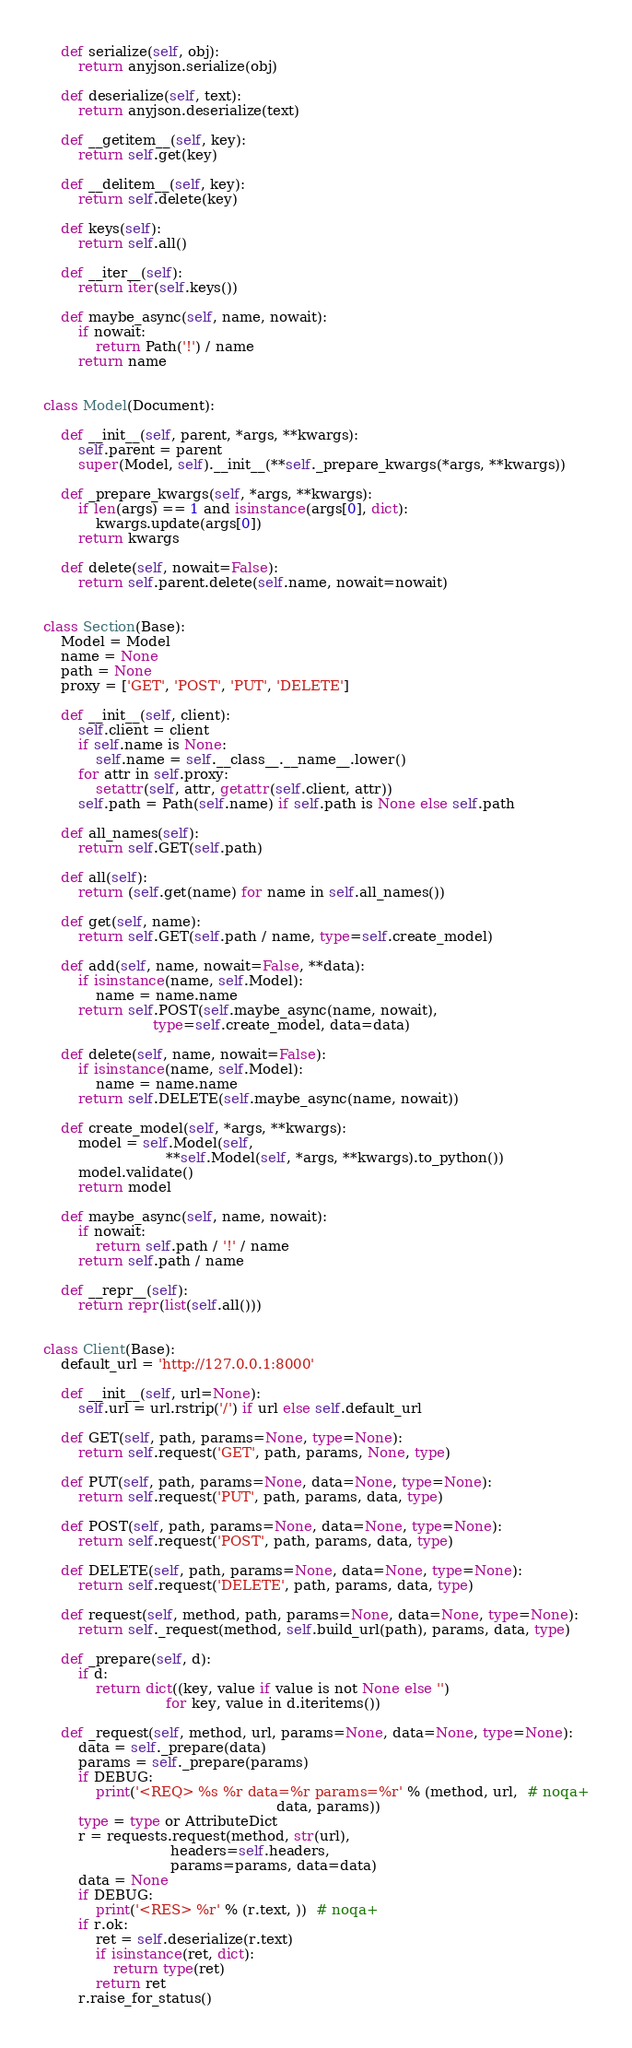Convert code to text. <code><loc_0><loc_0><loc_500><loc_500><_Python_>
    def serialize(self, obj):
        return anyjson.serialize(obj)

    def deserialize(self, text):
        return anyjson.deserialize(text)

    def __getitem__(self, key):
        return self.get(key)

    def __delitem__(self, key):
        return self.delete(key)

    def keys(self):
        return self.all()

    def __iter__(self):
        return iter(self.keys())

    def maybe_async(self, name, nowait):
        if nowait:
            return Path('!') / name
        return name


class Model(Document):

    def __init__(self, parent, *args, **kwargs):
        self.parent = parent
        super(Model, self).__init__(**self._prepare_kwargs(*args, **kwargs))

    def _prepare_kwargs(self, *args, **kwargs):
        if len(args) == 1 and isinstance(args[0], dict):
            kwargs.update(args[0])
        return kwargs

    def delete(self, nowait=False):
        return self.parent.delete(self.name, nowait=nowait)


class Section(Base):
    Model = Model
    name = None
    path = None
    proxy = ['GET', 'POST', 'PUT', 'DELETE']

    def __init__(self, client):
        self.client = client
        if self.name is None:
            self.name = self.__class__.__name__.lower()
        for attr in self.proxy:
            setattr(self, attr, getattr(self.client, attr))
        self.path = Path(self.name) if self.path is None else self.path

    def all_names(self):
        return self.GET(self.path)

    def all(self):
        return (self.get(name) for name in self.all_names())

    def get(self, name):
        return self.GET(self.path / name, type=self.create_model)

    def add(self, name, nowait=False, **data):
        if isinstance(name, self.Model):
            name = name.name
        return self.POST(self.maybe_async(name, nowait),
                         type=self.create_model, data=data)

    def delete(self, name, nowait=False):
        if isinstance(name, self.Model):
            name = name.name
        return self.DELETE(self.maybe_async(name, nowait))

    def create_model(self, *args, **kwargs):
        model = self.Model(self,
                            **self.Model(self, *args, **kwargs).to_python())
        model.validate()
        return model

    def maybe_async(self, name, nowait):
        if nowait:
            return self.path / '!' / name
        return self.path / name

    def __repr__(self):
        return repr(list(self.all()))


class Client(Base):
    default_url = 'http://127.0.0.1:8000'

    def __init__(self, url=None):
        self.url = url.rstrip('/') if url else self.default_url

    def GET(self, path, params=None, type=None):
        return self.request('GET', path, params, None, type)

    def PUT(self, path, params=None, data=None, type=None):
        return self.request('PUT', path, params, data, type)

    def POST(self, path, params=None, data=None, type=None):
        return self.request('POST', path, params, data, type)

    def DELETE(self, path, params=None, data=None, type=None):
        return self.request('DELETE', path, params, data, type)

    def request(self, method, path, params=None, data=None, type=None):
        return self._request(method, self.build_url(path), params, data, type)

    def _prepare(self, d):
        if d:
            return dict((key, value if value is not None else '')
                            for key, value in d.iteritems())

    def _request(self, method, url, params=None, data=None, type=None):
        data = self._prepare(data)
        params = self._prepare(params)
        if DEBUG:
            print('<REQ> %s %r data=%r params=%r' % (method, url,  # noqa+
                                                     data, params))
        type = type or AttributeDict
        r = requests.request(method, str(url),
                             headers=self.headers,
                             params=params, data=data)
        data = None
        if DEBUG:
            print('<RES> %r' % (r.text, ))  # noqa+
        if r.ok:
            ret = self.deserialize(r.text)
            if isinstance(ret, dict):
                return type(ret)
            return ret
        r.raise_for_status()
</code> 